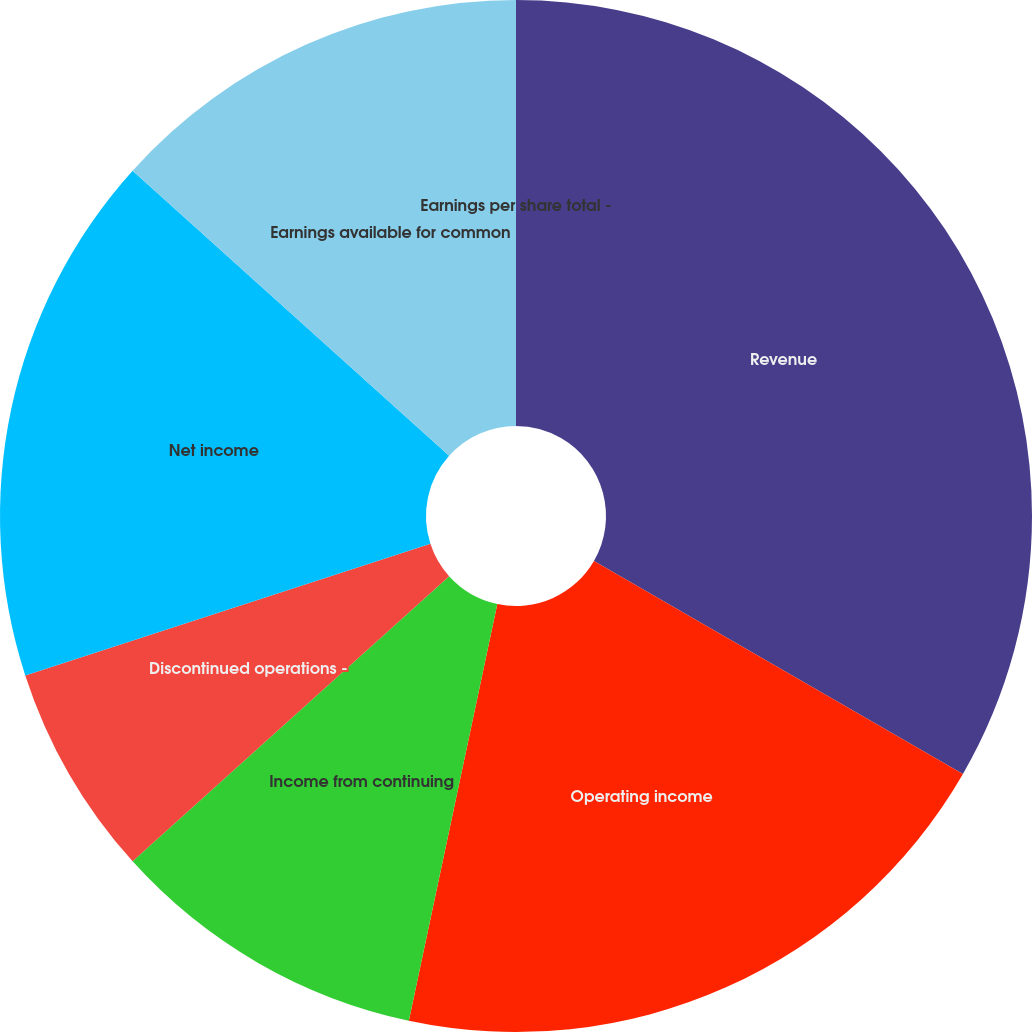<chart> <loc_0><loc_0><loc_500><loc_500><pie_chart><fcel>Revenue<fcel>Operating income<fcel>Income from continuing<fcel>Discontinued operations -<fcel>Net income<fcel>Earnings available for common<fcel>Earnings per share total -<nl><fcel>33.33%<fcel>20.0%<fcel>10.0%<fcel>6.67%<fcel>16.67%<fcel>13.33%<fcel>0.0%<nl></chart> 